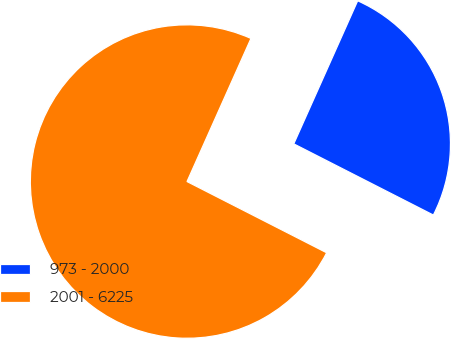Convert chart. <chart><loc_0><loc_0><loc_500><loc_500><pie_chart><fcel>973 - 2000<fcel>2001 - 6225<nl><fcel>25.82%<fcel>74.18%<nl></chart> 